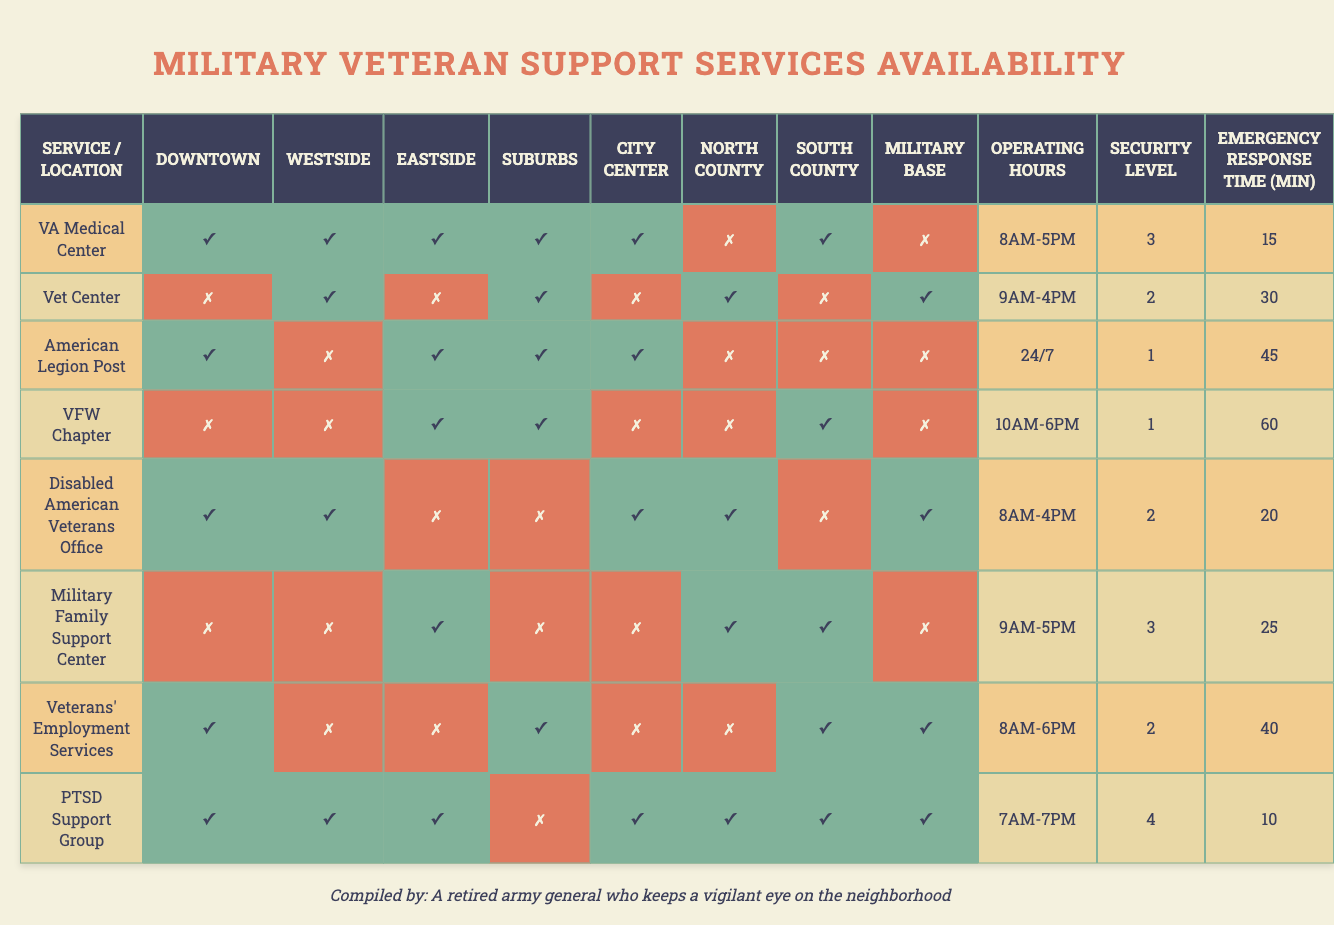What services are available in the Downtown location? Referring to the Downtown column, the available services are VA Medical Center, American Legion Post, and Veterans' Employment Services, as indicated by the check marks (✓) in those rows.
Answer: VA Medical Center, American Legion Post, Veterans' Employment Services Which service has the highest security level? Reviewing the security levels, Military Family Support Center has the highest security level of 3, while others have lower values, making it the highest.
Answer: Military Family Support Center Is the Veterans' Employment Services available in the Eastside? Looking at the Eastside column for Veterans' Employment Services, it shows a cross (✗), indicating it is not available at that location.
Answer: No How many services are available in the City Center? Checking the City Center column, there are 5 services marked as available with check marks (✓), which are VA Medical Center, Vet Center, VFW Chapter, Disabled American Veterans Office, and PTSD Support Group.
Answer: 5 What is the emergency response time of the Military Family Support Center? Looking for the Military Family Support Center in the corresponding row, the emergency response time is listed as 25 minutes.
Answer: 25 minutes What is the average security level of services located in the North County? North County has 3 services (Military Family Support Center, Veterans' Employment Services, and Disabled American Veterans Office) with security levels of 3, 2, and 1 respectively. Summing them gives 3 + 2 + 1 = 6, and dividing by 3 gives an average of 2.
Answer: 2 Are there any services available in the South County? Referring to the South County column, a cross (✗) indicates that some services are not available, but others, such as VA Medical Center and Disabled American Veterans Office, are available.
Answer: Yes Which service operates 24/7 and is available in multiple locations? The service that operates 24/7 is the VFW Chapter, which is available in Eastside and Military Base.
Answer: VFW Chapter How many services operate outside of standard business hours? Services operating outside of standard business hours (8AM-5PM) are VFW Chapter (10AM-6PM) and PTSD Support Group (7AM-7PM). Thus, there are 2 such services.
Answer: 2 Which location has the shortest emergency response time, and how long is it? Checking the emergency response times, the shortest is 10 minutes, associated with the PTSD Support Group located in Military Base.
Answer: Military Base, 10 minutes 